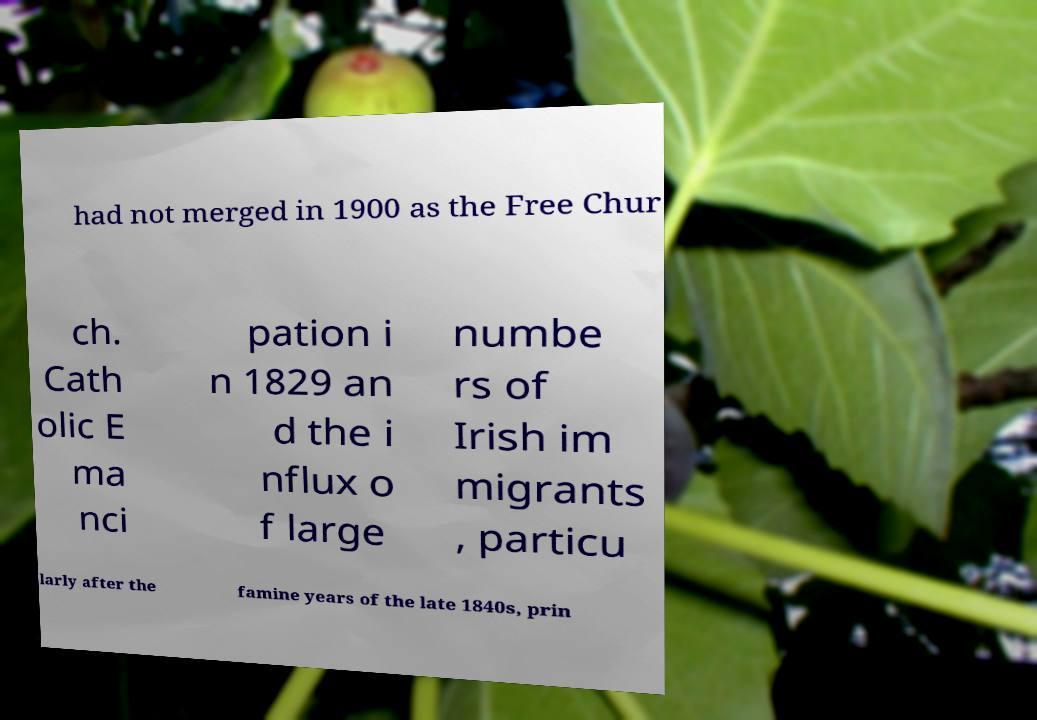Could you extract and type out the text from this image? had not merged in 1900 as the Free Chur ch. Cath olic E ma nci pation i n 1829 an d the i nflux o f large numbe rs of Irish im migrants , particu larly after the famine years of the late 1840s, prin 